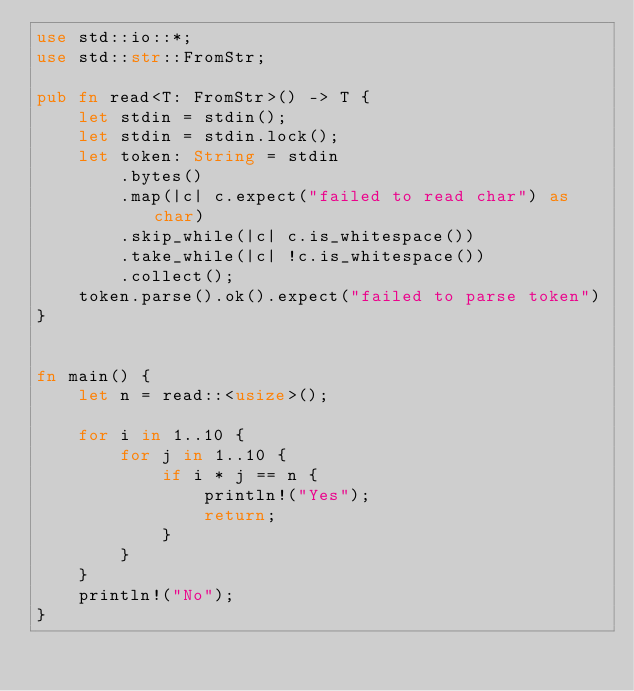<code> <loc_0><loc_0><loc_500><loc_500><_Rust_>use std::io::*;
use std::str::FromStr;

pub fn read<T: FromStr>() -> T {
    let stdin = stdin();
    let stdin = stdin.lock();
    let token: String = stdin
        .bytes()
        .map(|c| c.expect("failed to read char") as char)
        .skip_while(|c| c.is_whitespace())
        .take_while(|c| !c.is_whitespace())
        .collect();
    token.parse().ok().expect("failed to parse token")
}


fn main() {
    let n = read::<usize>();

    for i in 1..10 {
        for j in 1..10 {
            if i * j == n {
                println!("Yes");
                return;
            }
        }
    }
    println!("No");
}
</code> 